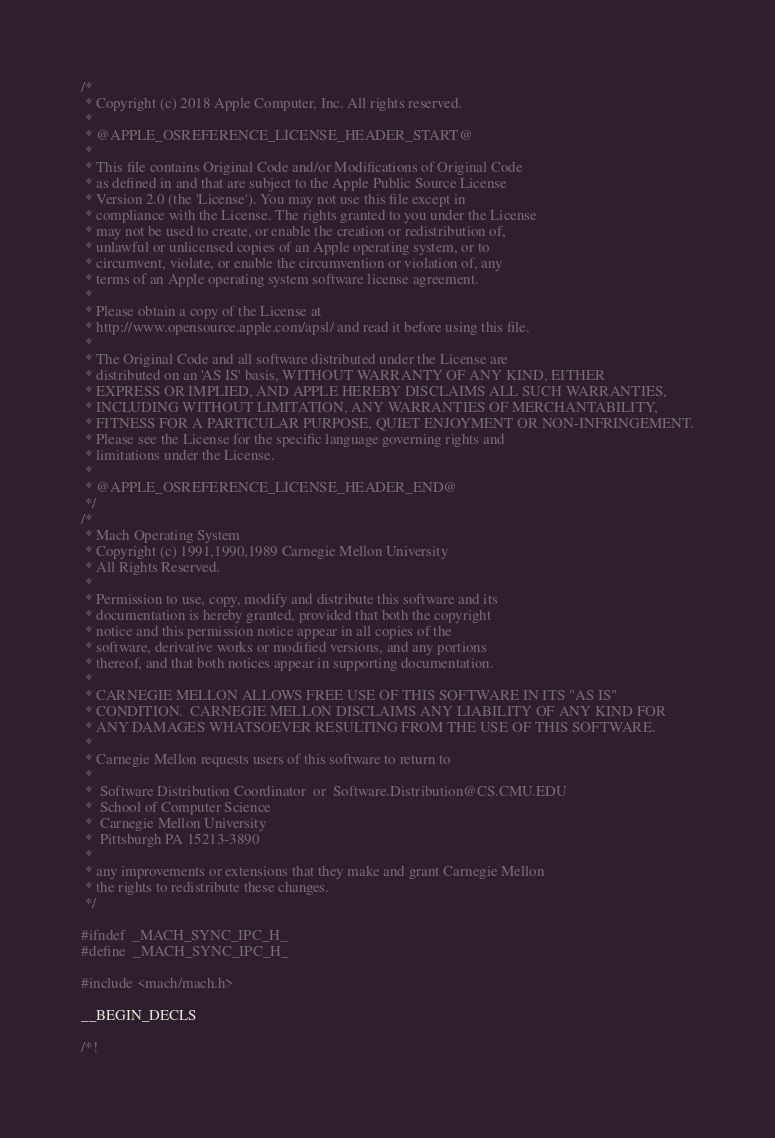Convert code to text. <code><loc_0><loc_0><loc_500><loc_500><_C_>/*
 * Copyright (c) 2018 Apple Computer, Inc. All rights reserved.
 *
 * @APPLE_OSREFERENCE_LICENSE_HEADER_START@
 * 
 * This file contains Original Code and/or Modifications of Original Code
 * as defined in and that are subject to the Apple Public Source License
 * Version 2.0 (the 'License'). You may not use this file except in
 * compliance with the License. The rights granted to you under the License
 * may not be used to create, or enable the creation or redistribution of,
 * unlawful or unlicensed copies of an Apple operating system, or to
 * circumvent, violate, or enable the circumvention or violation of, any
 * terms of an Apple operating system software license agreement.
 * 
 * Please obtain a copy of the License at
 * http://www.opensource.apple.com/apsl/ and read it before using this file.
 * 
 * The Original Code and all software distributed under the License are
 * distributed on an 'AS IS' basis, WITHOUT WARRANTY OF ANY KIND, EITHER
 * EXPRESS OR IMPLIED, AND APPLE HEREBY DISCLAIMS ALL SUCH WARRANTIES,
 * INCLUDING WITHOUT LIMITATION, ANY WARRANTIES OF MERCHANTABILITY,
 * FITNESS FOR A PARTICULAR PURPOSE, QUIET ENJOYMENT OR NON-INFRINGEMENT.
 * Please see the License for the specific language governing rights and
 * limitations under the License.
 * 
 * @APPLE_OSREFERENCE_LICENSE_HEADER_END@
 */
/* 
 * Mach Operating System
 * Copyright (c) 1991,1990,1989 Carnegie Mellon University
 * All Rights Reserved.
 * 
 * Permission to use, copy, modify and distribute this software and its
 * documentation is hereby granted, provided that both the copyright
 * notice and this permission notice appear in all copies of the
 * software, derivative works or modified versions, and any portions
 * thereof, and that both notices appear in supporting documentation.
 * 
 * CARNEGIE MELLON ALLOWS FREE USE OF THIS SOFTWARE IN ITS "AS IS"
 * CONDITION.  CARNEGIE MELLON DISCLAIMS ANY LIABILITY OF ANY KIND FOR
 * ANY DAMAGES WHATSOEVER RESULTING FROM THE USE OF THIS SOFTWARE.
 * 
 * Carnegie Mellon requests users of this software to return to
 * 
 *  Software Distribution Coordinator  or  Software.Distribution@CS.CMU.EDU
 *  School of Computer Science
 *  Carnegie Mellon University
 *  Pittsburgh PA 15213-3890
 * 
 * any improvements or extensions that they make and grant Carnegie Mellon
 * the rights to redistribute these changes.
 */

#ifndef	_MACH_SYNC_IPC_H_
#define	_MACH_SYNC_IPC_H_

#include <mach/mach.h>

__BEGIN_DECLS

/*!</code> 